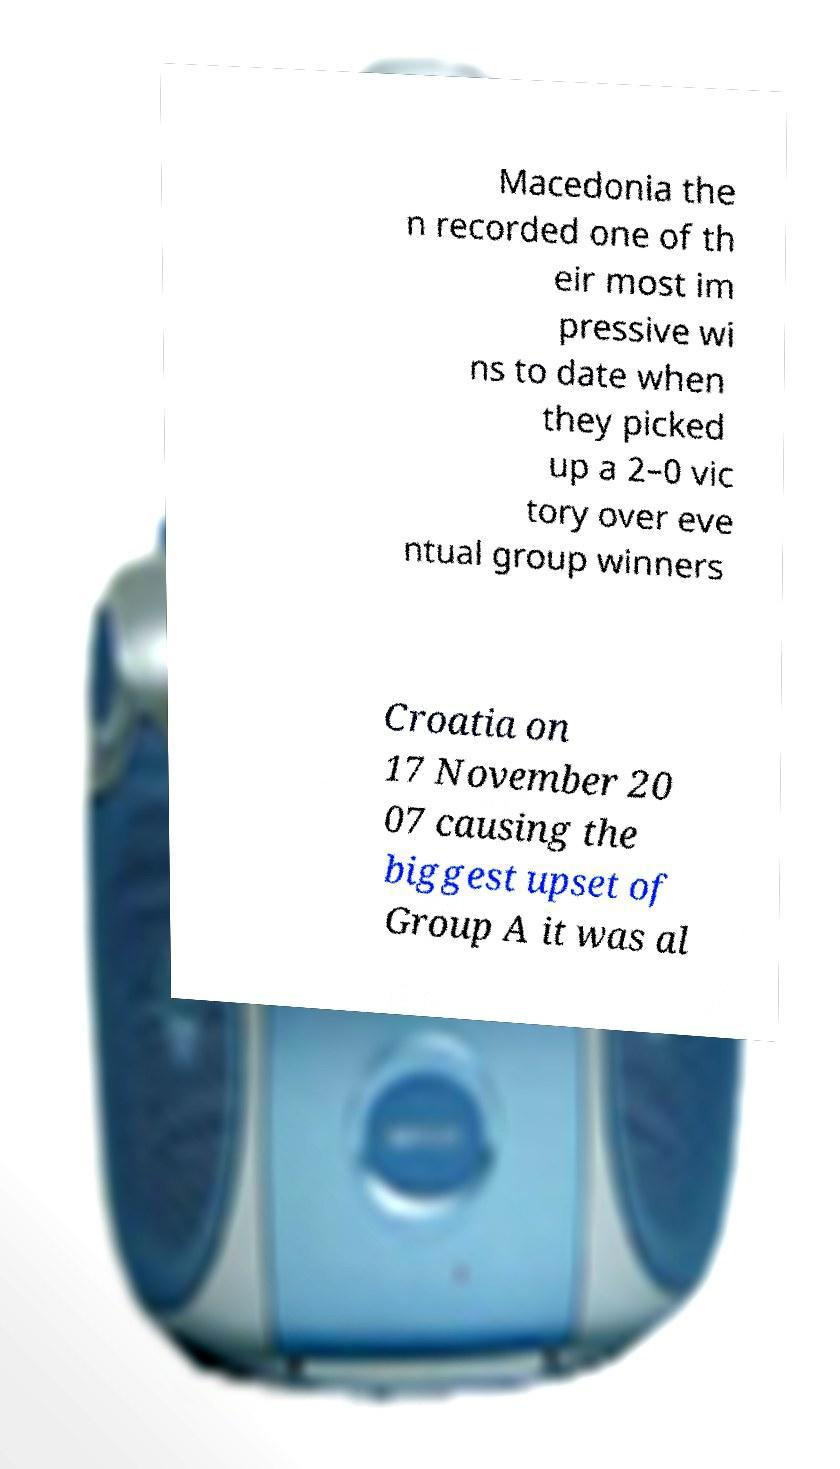For documentation purposes, I need the text within this image transcribed. Could you provide that? Macedonia the n recorded one of th eir most im pressive wi ns to date when they picked up a 2–0 vic tory over eve ntual group winners Croatia on 17 November 20 07 causing the biggest upset of Group A it was al 